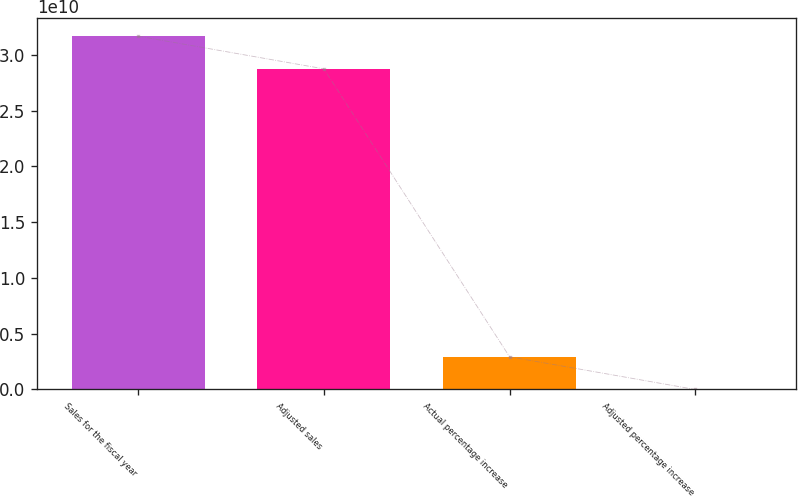Convert chart. <chart><loc_0><loc_0><loc_500><loc_500><bar_chart><fcel>Sales for the fiscal year<fcel>Adjusted sales<fcel>Actual percentage increase<fcel>Adjusted percentage increase<nl><fcel>3.16876e+10<fcel>2.8754e+10<fcel>2.93354e+09<fcel>10<nl></chart> 